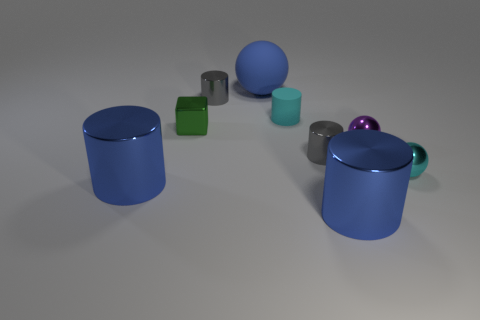Subtract all large blue balls. How many balls are left? 2 Subtract all balls. How many objects are left? 6 Subtract 2 cylinders. How many cylinders are left? 3 Add 2 purple metallic spheres. How many purple metallic spheres are left? 3 Add 7 small metallic cylinders. How many small metallic cylinders exist? 9 Add 1 tiny spheres. How many objects exist? 10 Subtract all gray cylinders. How many cylinders are left? 3 Subtract 0 gray balls. How many objects are left? 9 Subtract all gray cylinders. Subtract all green spheres. How many cylinders are left? 3 Subtract all brown cylinders. How many cyan spheres are left? 1 